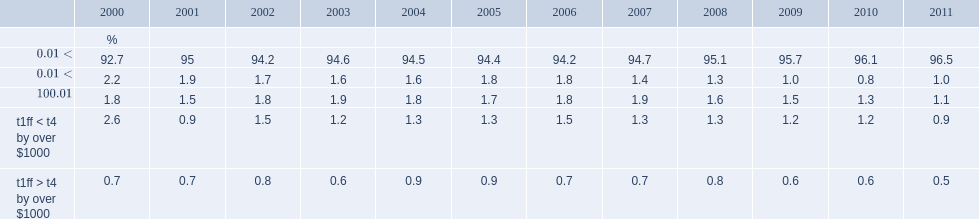What is the percentage of cases on average in each year show a difference between t1ff and t4 file of no more than one dollar between data sources? 94.808333. What is the percentage of cases on average in each year show a difference between t1ff and t4 earnings of no more than one thousand dollars between data sources? 97.958333. 